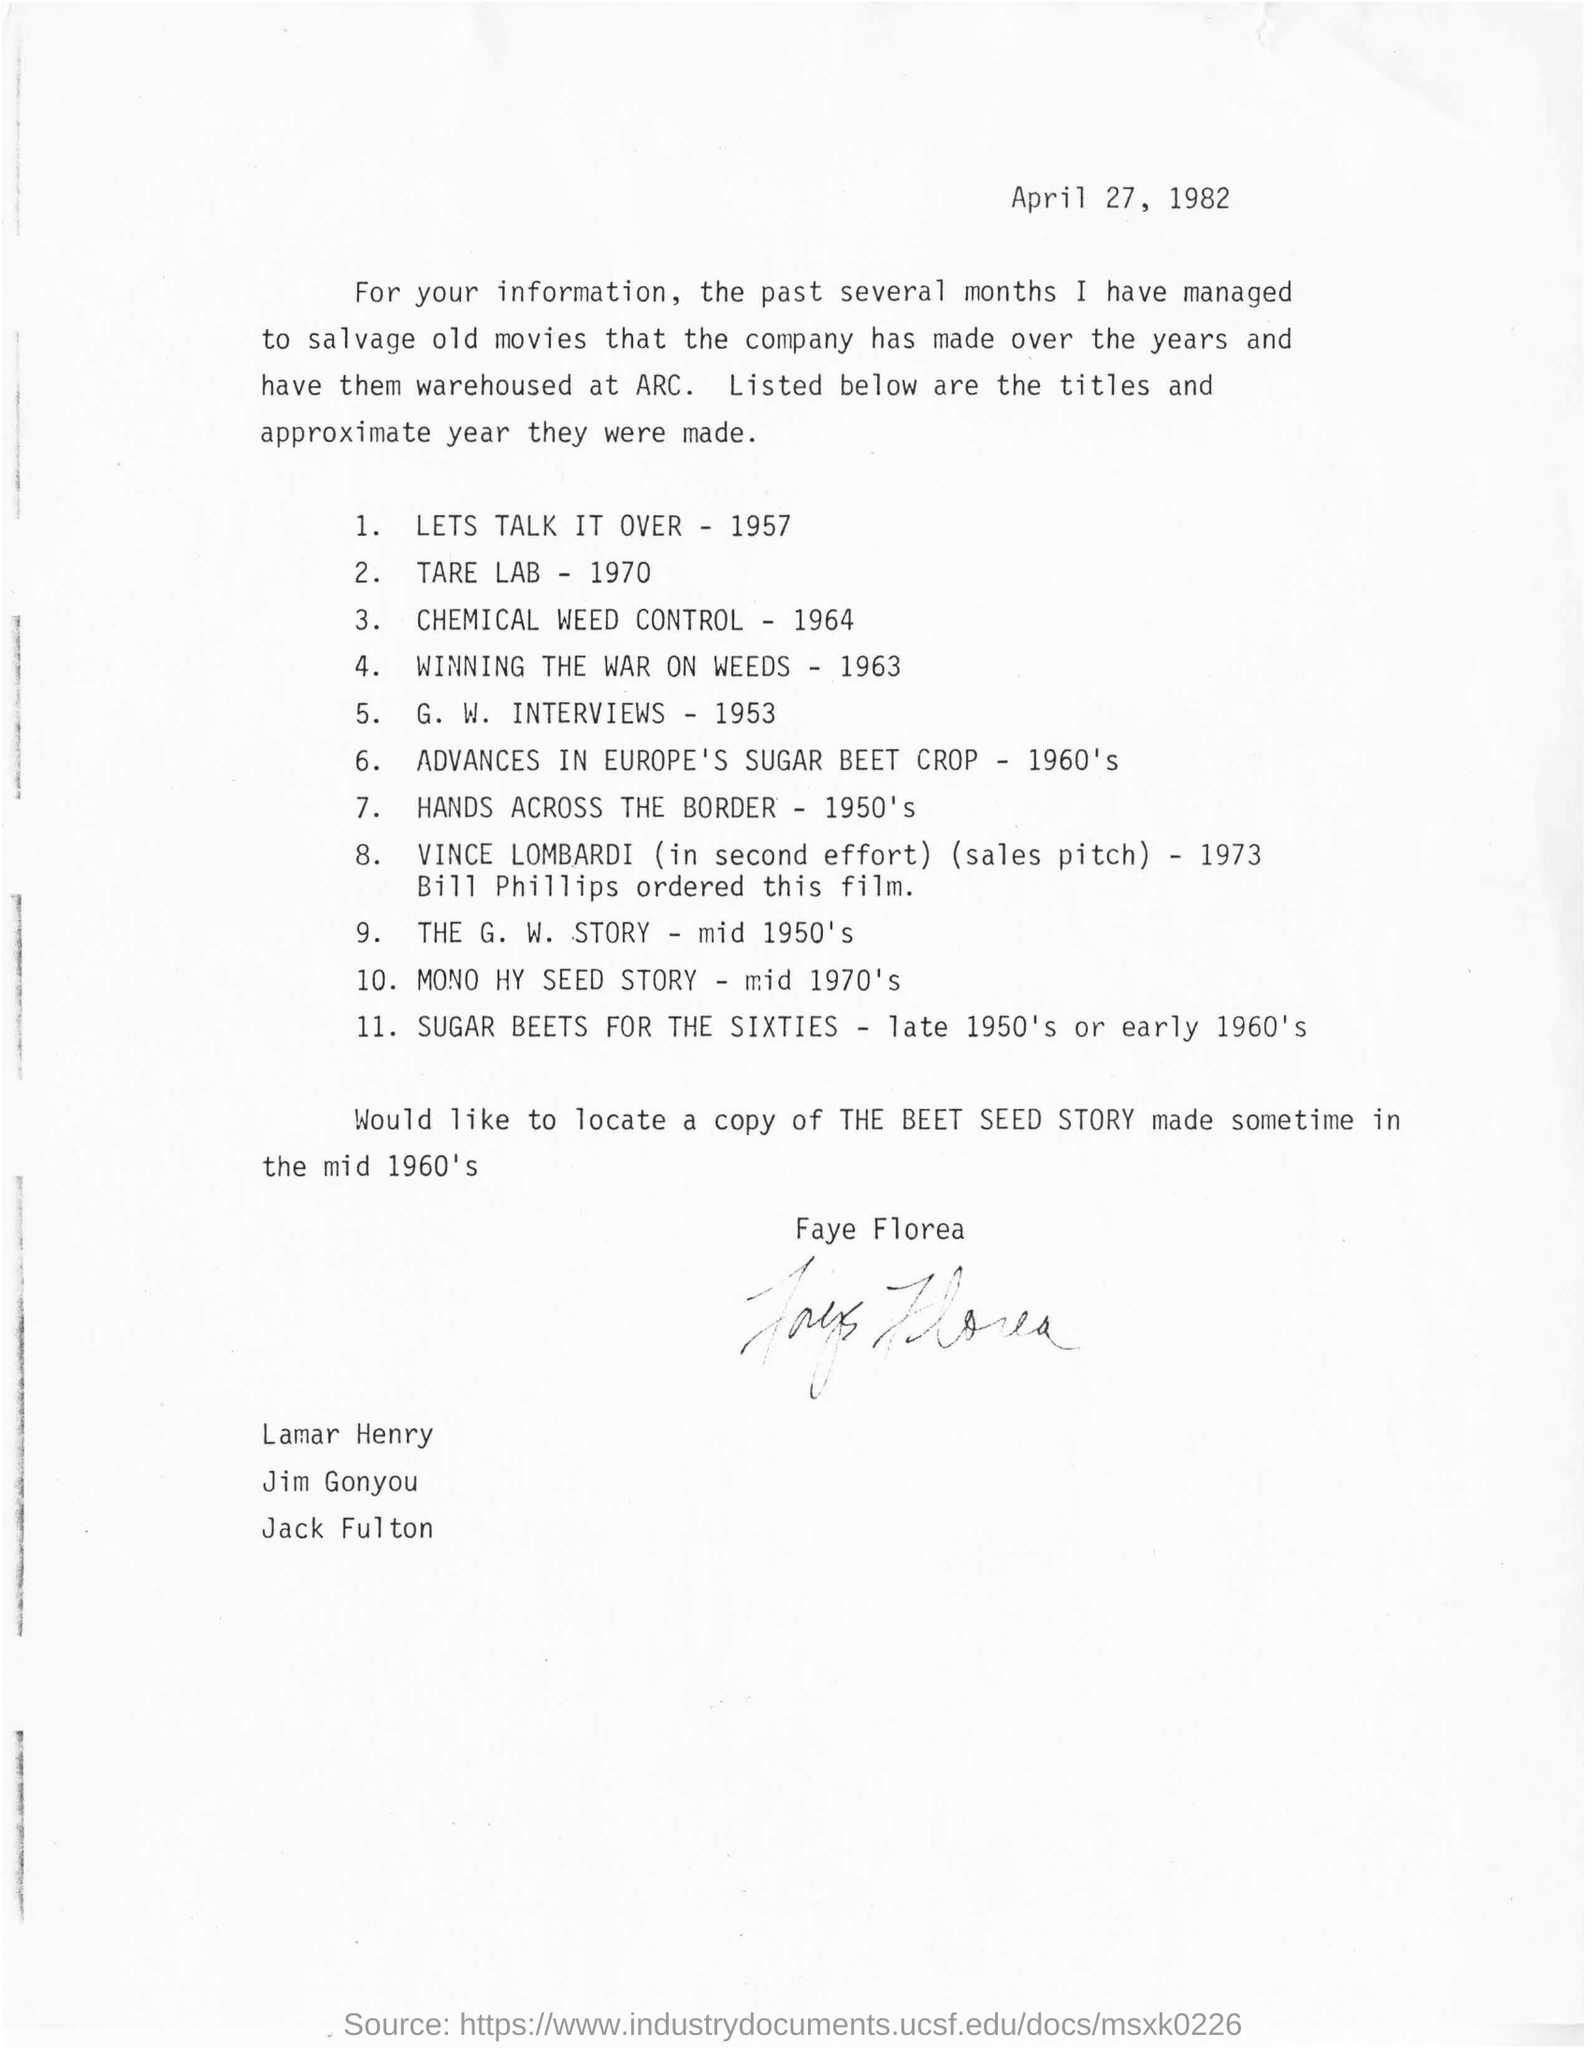Give some essential details in this illustration. The signature at the bottom of the letter is that of Faye Florea. The title of the G.W. INTERVIEWS movie was made in the year 1953. In 1973, Bill Phillips ordered the Vince Lombardi film. The date mentioned in this letter is April 27, 1982. The film made in the late 1950's or early 1960's is "Sugar Beets for the Sixties. 